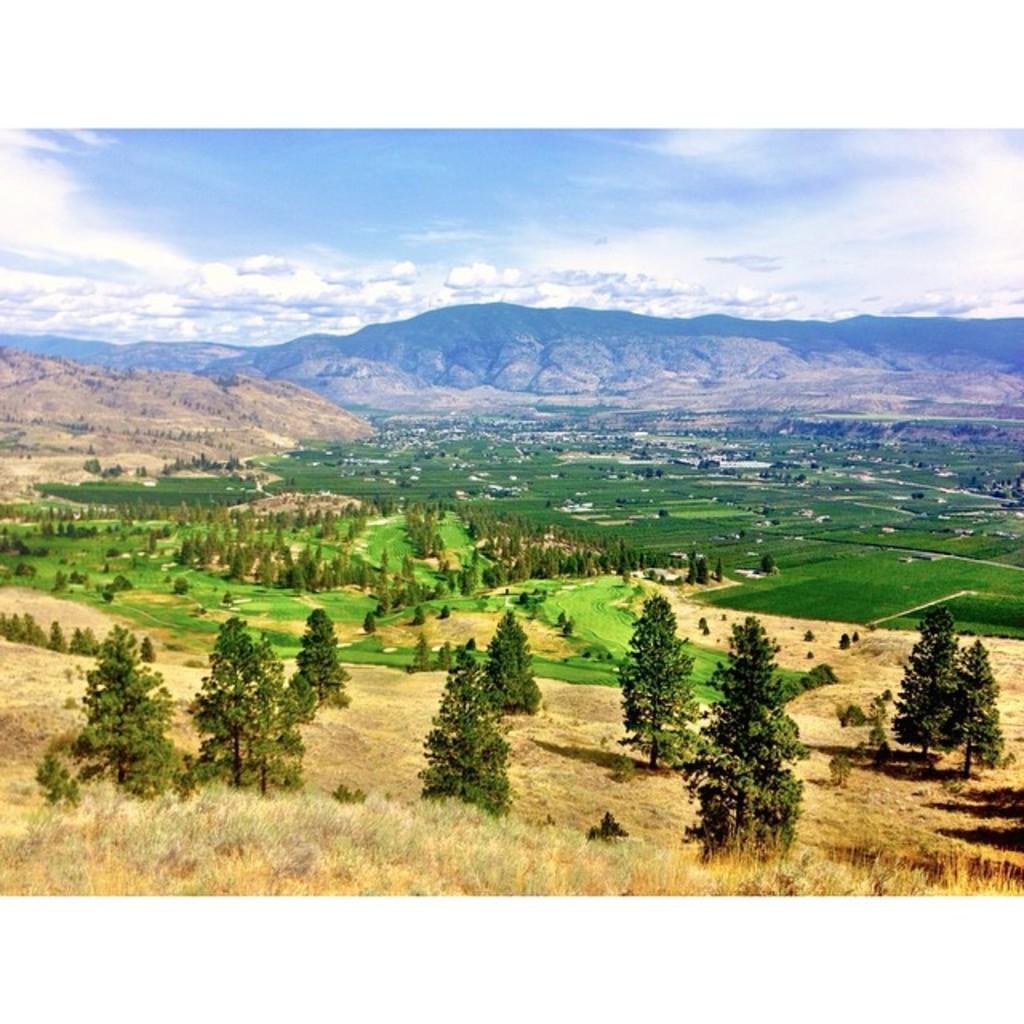Describe this image in one or two sentences. In this image few trees are on the grassland. Background there are few hills. Top of the image there is sky with some clouds. 